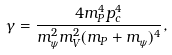<formula> <loc_0><loc_0><loc_500><loc_500>\gamma = \frac { 4 m _ { P } ^ { 4 } p _ { c } ^ { 4 } } { m _ { \psi } ^ { 2 } m _ { V } ^ { 2 } ( m _ { P } + m _ { \psi } ) ^ { 4 } } ,</formula> 